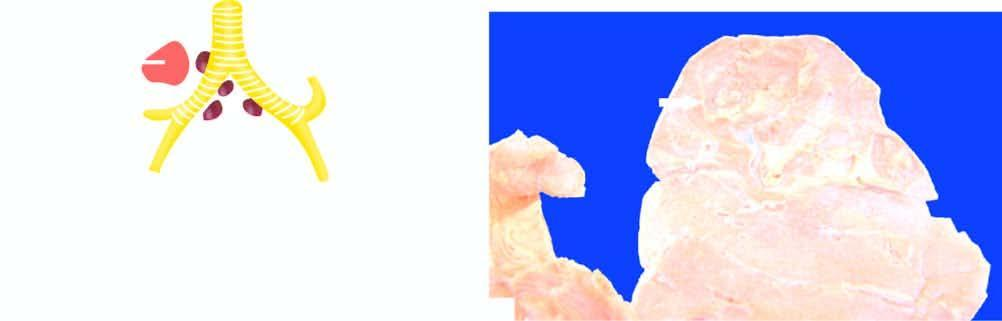s there consolidation of lung parenchyma surrounding the cavity?
Answer the question using a single word or phrase. Yes 